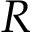Convert formula to latex. <formula><loc_0><loc_0><loc_500><loc_500>R</formula> 